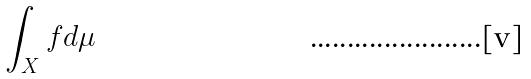<formula> <loc_0><loc_0><loc_500><loc_500>\int _ { X } f d \mu</formula> 